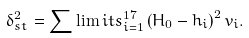<formula> <loc_0><loc_0><loc_500><loc_500>\delta _ { s t } ^ { 2 } = \sum \lim i t s _ { i = 1 } ^ { 1 7 } \left ( H _ { 0 } - h _ { i } \right ) ^ { 2 } v _ { i } .</formula> 